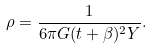<formula> <loc_0><loc_0><loc_500><loc_500>\rho = \frac { 1 } { 6 \pi G ( t + \beta ) ^ { 2 } Y } .</formula> 